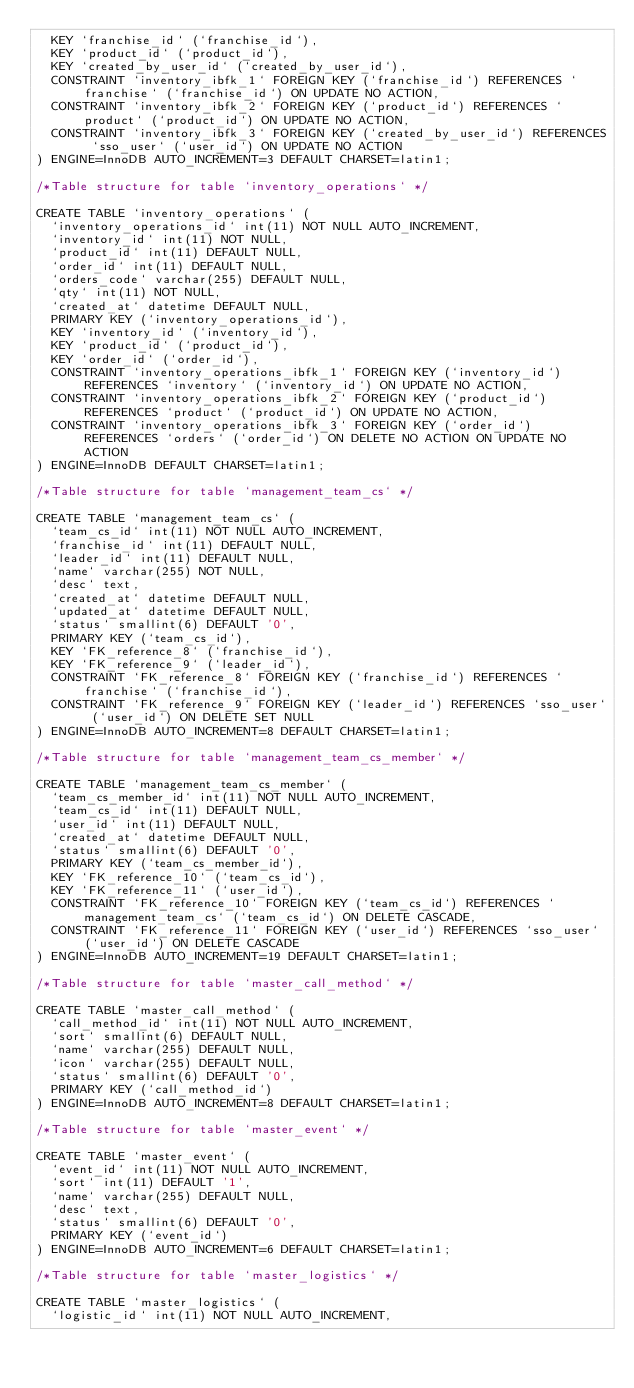<code> <loc_0><loc_0><loc_500><loc_500><_SQL_>  KEY `franchise_id` (`franchise_id`),
  KEY `product_id` (`product_id`),
  KEY `created_by_user_id` (`created_by_user_id`),
  CONSTRAINT `inventory_ibfk_1` FOREIGN KEY (`franchise_id`) REFERENCES `franchise` (`franchise_id`) ON UPDATE NO ACTION,
  CONSTRAINT `inventory_ibfk_2` FOREIGN KEY (`product_id`) REFERENCES `product` (`product_id`) ON UPDATE NO ACTION,
  CONSTRAINT `inventory_ibfk_3` FOREIGN KEY (`created_by_user_id`) REFERENCES `sso_user` (`user_id`) ON UPDATE NO ACTION
) ENGINE=InnoDB AUTO_INCREMENT=3 DEFAULT CHARSET=latin1;

/*Table structure for table `inventory_operations` */

CREATE TABLE `inventory_operations` (
  `inventory_operations_id` int(11) NOT NULL AUTO_INCREMENT,
  `inventory_id` int(11) NOT NULL,
  `product_id` int(11) DEFAULT NULL,
  `order_id` int(11) DEFAULT NULL,
  `orders_code` varchar(255) DEFAULT NULL,
  `qty` int(11) NOT NULL,
  `created_at` datetime DEFAULT NULL,
  PRIMARY KEY (`inventory_operations_id`),
  KEY `inventory_id` (`inventory_id`),
  KEY `product_id` (`product_id`),
  KEY `order_id` (`order_id`),
  CONSTRAINT `inventory_operations_ibfk_1` FOREIGN KEY (`inventory_id`) REFERENCES `inventory` (`inventory_id`) ON UPDATE NO ACTION,
  CONSTRAINT `inventory_operations_ibfk_2` FOREIGN KEY (`product_id`) REFERENCES `product` (`product_id`) ON UPDATE NO ACTION,
  CONSTRAINT `inventory_operations_ibfk_3` FOREIGN KEY (`order_id`) REFERENCES `orders` (`order_id`) ON DELETE NO ACTION ON UPDATE NO ACTION
) ENGINE=InnoDB DEFAULT CHARSET=latin1;

/*Table structure for table `management_team_cs` */

CREATE TABLE `management_team_cs` (
  `team_cs_id` int(11) NOT NULL AUTO_INCREMENT,
  `franchise_id` int(11) DEFAULT NULL,
  `leader_id` int(11) DEFAULT NULL,
  `name` varchar(255) NOT NULL,
  `desc` text,
  `created_at` datetime DEFAULT NULL,
  `updated_at` datetime DEFAULT NULL,
  `status` smallint(6) DEFAULT '0',
  PRIMARY KEY (`team_cs_id`),
  KEY `FK_reference_8` (`franchise_id`),
  KEY `FK_reference_9` (`leader_id`),
  CONSTRAINT `FK_reference_8` FOREIGN KEY (`franchise_id`) REFERENCES `franchise` (`franchise_id`),
  CONSTRAINT `FK_reference_9` FOREIGN KEY (`leader_id`) REFERENCES `sso_user` (`user_id`) ON DELETE SET NULL
) ENGINE=InnoDB AUTO_INCREMENT=8 DEFAULT CHARSET=latin1;

/*Table structure for table `management_team_cs_member` */

CREATE TABLE `management_team_cs_member` (
  `team_cs_member_id` int(11) NOT NULL AUTO_INCREMENT,
  `team_cs_id` int(11) DEFAULT NULL,
  `user_id` int(11) DEFAULT NULL,
  `created_at` datetime DEFAULT NULL,
  `status` smallint(6) DEFAULT '0',
  PRIMARY KEY (`team_cs_member_id`),
  KEY `FK_reference_10` (`team_cs_id`),
  KEY `FK_reference_11` (`user_id`),
  CONSTRAINT `FK_reference_10` FOREIGN KEY (`team_cs_id`) REFERENCES `management_team_cs` (`team_cs_id`) ON DELETE CASCADE,
  CONSTRAINT `FK_reference_11` FOREIGN KEY (`user_id`) REFERENCES `sso_user` (`user_id`) ON DELETE CASCADE
) ENGINE=InnoDB AUTO_INCREMENT=19 DEFAULT CHARSET=latin1;

/*Table structure for table `master_call_method` */

CREATE TABLE `master_call_method` (
  `call_method_id` int(11) NOT NULL AUTO_INCREMENT,
  `sort` smallint(6) DEFAULT NULL,
  `name` varchar(255) DEFAULT NULL,
  `icon` varchar(255) DEFAULT NULL,
  `status` smallint(6) DEFAULT '0',
  PRIMARY KEY (`call_method_id`)
) ENGINE=InnoDB AUTO_INCREMENT=8 DEFAULT CHARSET=latin1;

/*Table structure for table `master_event` */

CREATE TABLE `master_event` (
  `event_id` int(11) NOT NULL AUTO_INCREMENT,
  `sort` int(11) DEFAULT '1',
  `name` varchar(255) DEFAULT NULL,
  `desc` text,
  `status` smallint(6) DEFAULT '0',
  PRIMARY KEY (`event_id`)
) ENGINE=InnoDB AUTO_INCREMENT=6 DEFAULT CHARSET=latin1;

/*Table structure for table `master_logistics` */

CREATE TABLE `master_logistics` (
  `logistic_id` int(11) NOT NULL AUTO_INCREMENT,</code> 